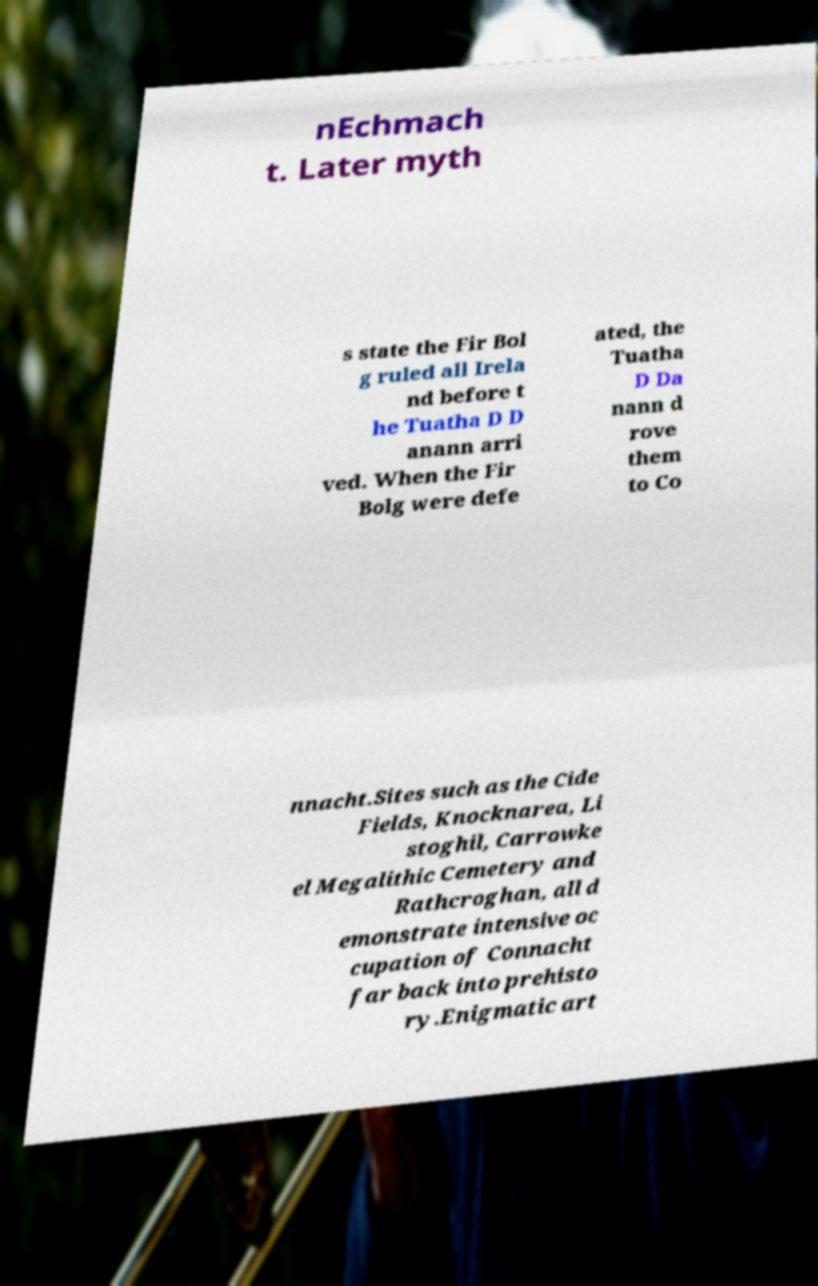Can you accurately transcribe the text from the provided image for me? nEchmach t. Later myth s state the Fir Bol g ruled all Irela nd before t he Tuatha D D anann arri ved. When the Fir Bolg were defe ated, the Tuatha D Da nann d rove them to Co nnacht.Sites such as the Cide Fields, Knocknarea, Li stoghil, Carrowke el Megalithic Cemetery and Rathcroghan, all d emonstrate intensive oc cupation of Connacht far back into prehisto ry.Enigmatic art 